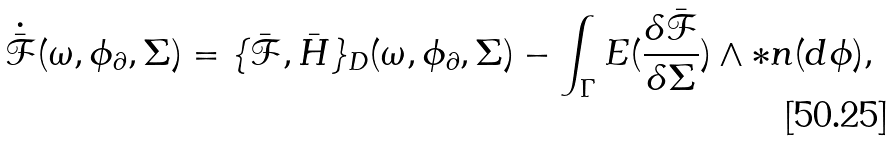<formula> <loc_0><loc_0><loc_500><loc_500>\dot { \bar { \mathcal { F } } } ( \omega , \phi _ { \partial } , \Sigma ) = \{ \bar { \mathcal { F } } , \bar { H } \} _ { D } ( \omega , \phi _ { \partial } , \Sigma ) - \int _ { \Gamma } E ( \frac { \delta \bar { \mathcal { F } } } { \delta \Sigma } ) \wedge \ast n ( d \phi ) ,</formula> 